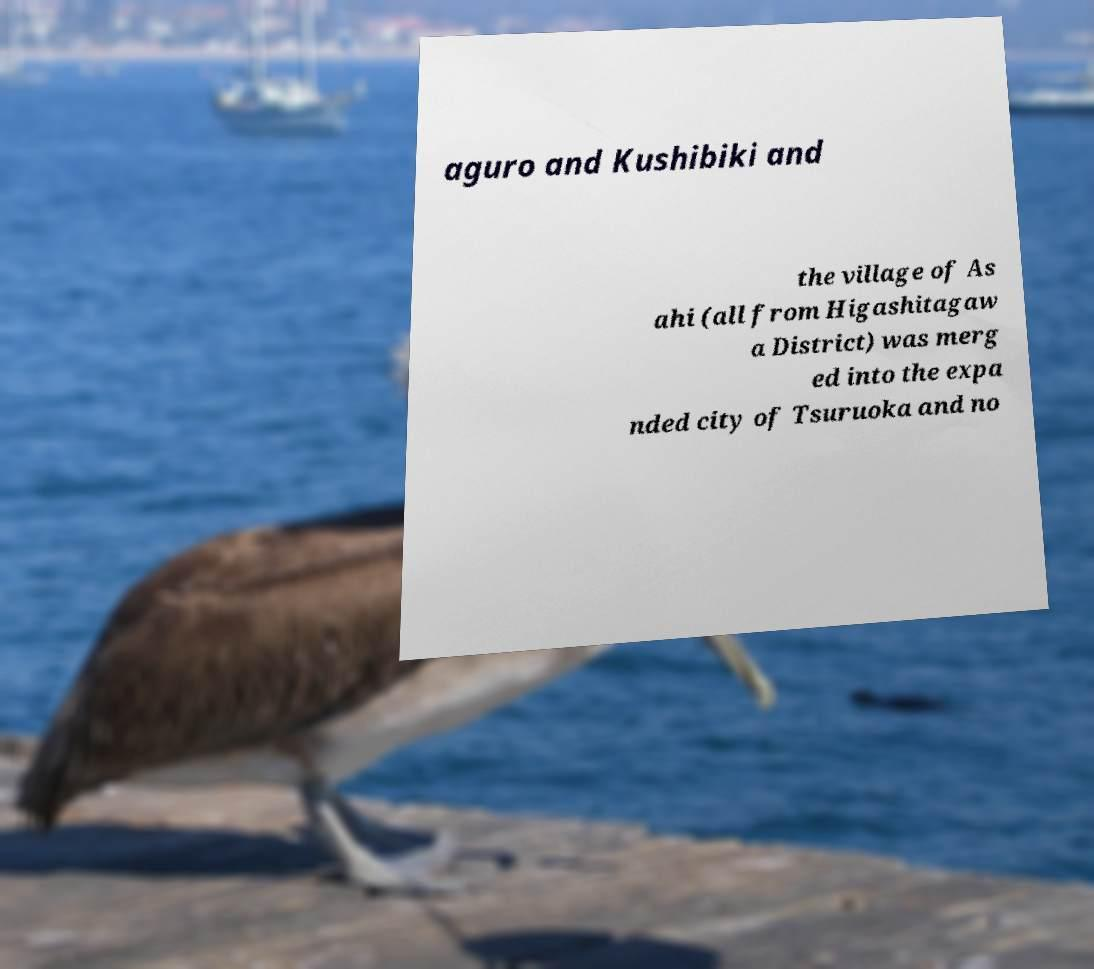Can you accurately transcribe the text from the provided image for me? aguro and Kushibiki and the village of As ahi (all from Higashitagaw a District) was merg ed into the expa nded city of Tsuruoka and no 